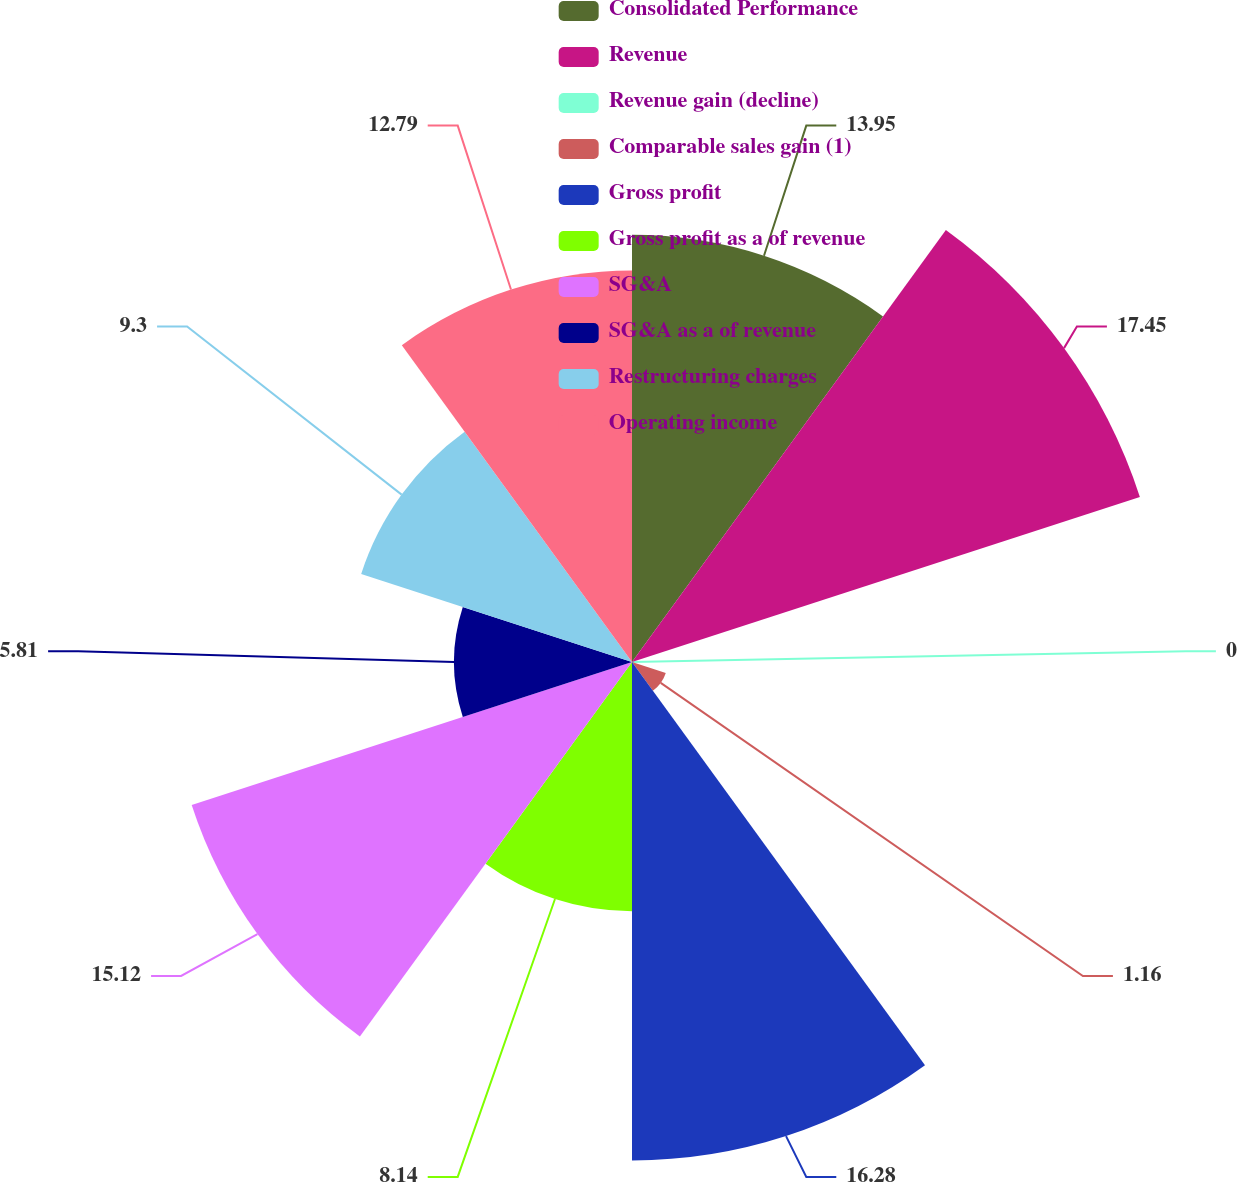<chart> <loc_0><loc_0><loc_500><loc_500><pie_chart><fcel>Consolidated Performance<fcel>Revenue<fcel>Revenue gain (decline)<fcel>Comparable sales gain (1)<fcel>Gross profit<fcel>Gross profit as a of revenue<fcel>SG&A<fcel>SG&A as a of revenue<fcel>Restructuring charges<fcel>Operating income<nl><fcel>13.95%<fcel>17.44%<fcel>0.0%<fcel>1.16%<fcel>16.28%<fcel>8.14%<fcel>15.12%<fcel>5.81%<fcel>9.3%<fcel>12.79%<nl></chart> 